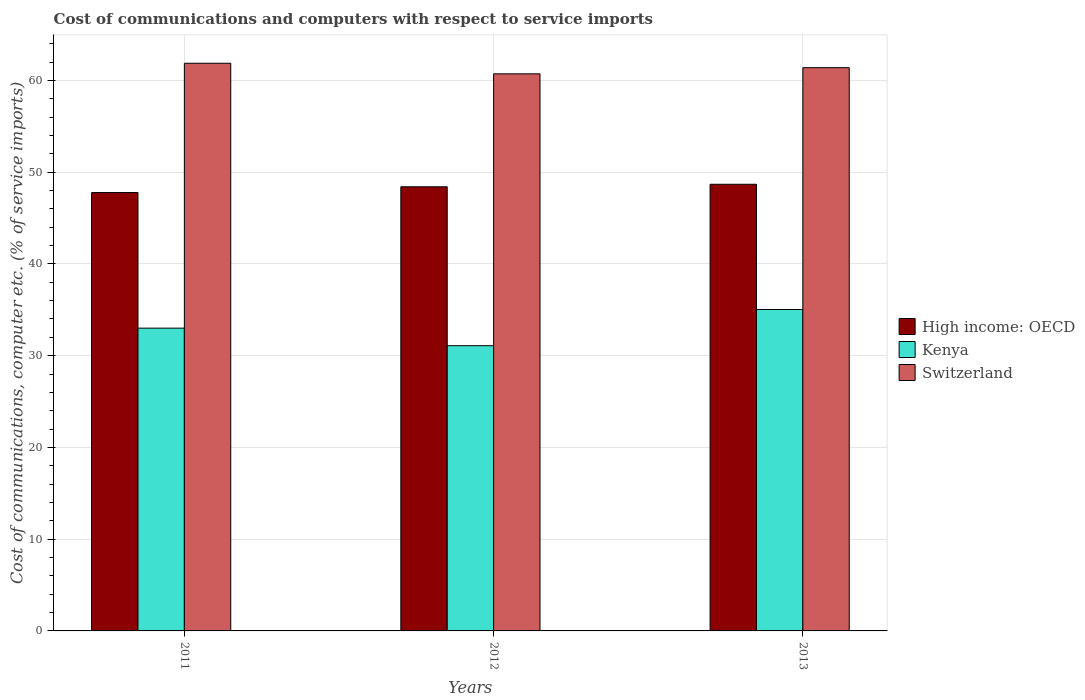How many groups of bars are there?
Ensure brevity in your answer.  3. How many bars are there on the 2nd tick from the left?
Make the answer very short. 3. How many bars are there on the 2nd tick from the right?
Make the answer very short. 3. What is the label of the 1st group of bars from the left?
Keep it short and to the point. 2011. What is the cost of communications and computers in High income: OECD in 2011?
Ensure brevity in your answer.  47.78. Across all years, what is the maximum cost of communications and computers in Switzerland?
Give a very brief answer. 61.87. Across all years, what is the minimum cost of communications and computers in High income: OECD?
Your response must be concise. 47.78. What is the total cost of communications and computers in Kenya in the graph?
Give a very brief answer. 99.12. What is the difference between the cost of communications and computers in Switzerland in 2012 and that in 2013?
Provide a succinct answer. -0.67. What is the difference between the cost of communications and computers in Kenya in 2012 and the cost of communications and computers in Switzerland in 2013?
Ensure brevity in your answer.  -30.3. What is the average cost of communications and computers in Kenya per year?
Ensure brevity in your answer.  33.04. In the year 2012, what is the difference between the cost of communications and computers in Switzerland and cost of communications and computers in High income: OECD?
Make the answer very short. 12.31. In how many years, is the cost of communications and computers in Switzerland greater than 40 %?
Offer a very short reply. 3. What is the ratio of the cost of communications and computers in High income: OECD in 2011 to that in 2012?
Offer a very short reply. 0.99. Is the difference between the cost of communications and computers in Switzerland in 2012 and 2013 greater than the difference between the cost of communications and computers in High income: OECD in 2012 and 2013?
Make the answer very short. No. What is the difference between the highest and the second highest cost of communications and computers in Kenya?
Offer a terse response. 2.03. What is the difference between the highest and the lowest cost of communications and computers in Kenya?
Provide a succinct answer. 3.94. In how many years, is the cost of communications and computers in Switzerland greater than the average cost of communications and computers in Switzerland taken over all years?
Your response must be concise. 2. What does the 3rd bar from the left in 2011 represents?
Offer a terse response. Switzerland. What does the 2nd bar from the right in 2011 represents?
Ensure brevity in your answer.  Kenya. Is it the case that in every year, the sum of the cost of communications and computers in Kenya and cost of communications and computers in High income: OECD is greater than the cost of communications and computers in Switzerland?
Keep it short and to the point. Yes. Are all the bars in the graph horizontal?
Offer a very short reply. No. How many years are there in the graph?
Keep it short and to the point. 3. What is the difference between two consecutive major ticks on the Y-axis?
Keep it short and to the point. 10. Are the values on the major ticks of Y-axis written in scientific E-notation?
Offer a terse response. No. Does the graph contain grids?
Offer a very short reply. Yes. How many legend labels are there?
Provide a short and direct response. 3. How are the legend labels stacked?
Provide a short and direct response. Vertical. What is the title of the graph?
Your answer should be compact. Cost of communications and computers with respect to service imports. What is the label or title of the Y-axis?
Your response must be concise. Cost of communications, computer etc. (% of service imports). What is the Cost of communications, computer etc. (% of service imports) in High income: OECD in 2011?
Your answer should be compact. 47.78. What is the Cost of communications, computer etc. (% of service imports) of Kenya in 2011?
Offer a very short reply. 33. What is the Cost of communications, computer etc. (% of service imports) of Switzerland in 2011?
Offer a very short reply. 61.87. What is the Cost of communications, computer etc. (% of service imports) in High income: OECD in 2012?
Provide a succinct answer. 48.41. What is the Cost of communications, computer etc. (% of service imports) in Kenya in 2012?
Your answer should be compact. 31.09. What is the Cost of communications, computer etc. (% of service imports) of Switzerland in 2012?
Give a very brief answer. 60.72. What is the Cost of communications, computer etc. (% of service imports) in High income: OECD in 2013?
Your answer should be compact. 48.68. What is the Cost of communications, computer etc. (% of service imports) in Kenya in 2013?
Ensure brevity in your answer.  35.03. What is the Cost of communications, computer etc. (% of service imports) in Switzerland in 2013?
Keep it short and to the point. 61.39. Across all years, what is the maximum Cost of communications, computer etc. (% of service imports) of High income: OECD?
Your response must be concise. 48.68. Across all years, what is the maximum Cost of communications, computer etc. (% of service imports) of Kenya?
Keep it short and to the point. 35.03. Across all years, what is the maximum Cost of communications, computer etc. (% of service imports) of Switzerland?
Give a very brief answer. 61.87. Across all years, what is the minimum Cost of communications, computer etc. (% of service imports) of High income: OECD?
Make the answer very short. 47.78. Across all years, what is the minimum Cost of communications, computer etc. (% of service imports) in Kenya?
Offer a terse response. 31.09. Across all years, what is the minimum Cost of communications, computer etc. (% of service imports) in Switzerland?
Keep it short and to the point. 60.72. What is the total Cost of communications, computer etc. (% of service imports) in High income: OECD in the graph?
Provide a short and direct response. 144.87. What is the total Cost of communications, computer etc. (% of service imports) of Kenya in the graph?
Your response must be concise. 99.12. What is the total Cost of communications, computer etc. (% of service imports) of Switzerland in the graph?
Provide a succinct answer. 183.98. What is the difference between the Cost of communications, computer etc. (% of service imports) of High income: OECD in 2011 and that in 2012?
Your answer should be compact. -0.63. What is the difference between the Cost of communications, computer etc. (% of service imports) of Kenya in 2011 and that in 2012?
Give a very brief answer. 1.91. What is the difference between the Cost of communications, computer etc. (% of service imports) in Switzerland in 2011 and that in 2012?
Your answer should be very brief. 1.15. What is the difference between the Cost of communications, computer etc. (% of service imports) in High income: OECD in 2011 and that in 2013?
Provide a short and direct response. -0.9. What is the difference between the Cost of communications, computer etc. (% of service imports) in Kenya in 2011 and that in 2013?
Offer a very short reply. -2.03. What is the difference between the Cost of communications, computer etc. (% of service imports) in Switzerland in 2011 and that in 2013?
Provide a short and direct response. 0.48. What is the difference between the Cost of communications, computer etc. (% of service imports) in High income: OECD in 2012 and that in 2013?
Keep it short and to the point. -0.27. What is the difference between the Cost of communications, computer etc. (% of service imports) in Kenya in 2012 and that in 2013?
Your answer should be very brief. -3.94. What is the difference between the Cost of communications, computer etc. (% of service imports) of Switzerland in 2012 and that in 2013?
Provide a succinct answer. -0.67. What is the difference between the Cost of communications, computer etc. (% of service imports) of High income: OECD in 2011 and the Cost of communications, computer etc. (% of service imports) of Kenya in 2012?
Your response must be concise. 16.69. What is the difference between the Cost of communications, computer etc. (% of service imports) of High income: OECD in 2011 and the Cost of communications, computer etc. (% of service imports) of Switzerland in 2012?
Give a very brief answer. -12.94. What is the difference between the Cost of communications, computer etc. (% of service imports) of Kenya in 2011 and the Cost of communications, computer etc. (% of service imports) of Switzerland in 2012?
Your answer should be very brief. -27.72. What is the difference between the Cost of communications, computer etc. (% of service imports) in High income: OECD in 2011 and the Cost of communications, computer etc. (% of service imports) in Kenya in 2013?
Ensure brevity in your answer.  12.75. What is the difference between the Cost of communications, computer etc. (% of service imports) in High income: OECD in 2011 and the Cost of communications, computer etc. (% of service imports) in Switzerland in 2013?
Offer a terse response. -13.61. What is the difference between the Cost of communications, computer etc. (% of service imports) in Kenya in 2011 and the Cost of communications, computer etc. (% of service imports) in Switzerland in 2013?
Ensure brevity in your answer.  -28.39. What is the difference between the Cost of communications, computer etc. (% of service imports) in High income: OECD in 2012 and the Cost of communications, computer etc. (% of service imports) in Kenya in 2013?
Make the answer very short. 13.37. What is the difference between the Cost of communications, computer etc. (% of service imports) in High income: OECD in 2012 and the Cost of communications, computer etc. (% of service imports) in Switzerland in 2013?
Ensure brevity in your answer.  -12.98. What is the difference between the Cost of communications, computer etc. (% of service imports) in Kenya in 2012 and the Cost of communications, computer etc. (% of service imports) in Switzerland in 2013?
Keep it short and to the point. -30.3. What is the average Cost of communications, computer etc. (% of service imports) in High income: OECD per year?
Your answer should be very brief. 48.29. What is the average Cost of communications, computer etc. (% of service imports) in Kenya per year?
Give a very brief answer. 33.04. What is the average Cost of communications, computer etc. (% of service imports) of Switzerland per year?
Offer a terse response. 61.33. In the year 2011, what is the difference between the Cost of communications, computer etc. (% of service imports) in High income: OECD and Cost of communications, computer etc. (% of service imports) in Kenya?
Your response must be concise. 14.78. In the year 2011, what is the difference between the Cost of communications, computer etc. (% of service imports) in High income: OECD and Cost of communications, computer etc. (% of service imports) in Switzerland?
Your answer should be very brief. -14.09. In the year 2011, what is the difference between the Cost of communications, computer etc. (% of service imports) in Kenya and Cost of communications, computer etc. (% of service imports) in Switzerland?
Make the answer very short. -28.87. In the year 2012, what is the difference between the Cost of communications, computer etc. (% of service imports) in High income: OECD and Cost of communications, computer etc. (% of service imports) in Kenya?
Your answer should be compact. 17.32. In the year 2012, what is the difference between the Cost of communications, computer etc. (% of service imports) in High income: OECD and Cost of communications, computer etc. (% of service imports) in Switzerland?
Make the answer very short. -12.31. In the year 2012, what is the difference between the Cost of communications, computer etc. (% of service imports) in Kenya and Cost of communications, computer etc. (% of service imports) in Switzerland?
Make the answer very short. -29.63. In the year 2013, what is the difference between the Cost of communications, computer etc. (% of service imports) in High income: OECD and Cost of communications, computer etc. (% of service imports) in Kenya?
Your response must be concise. 13.65. In the year 2013, what is the difference between the Cost of communications, computer etc. (% of service imports) in High income: OECD and Cost of communications, computer etc. (% of service imports) in Switzerland?
Give a very brief answer. -12.71. In the year 2013, what is the difference between the Cost of communications, computer etc. (% of service imports) in Kenya and Cost of communications, computer etc. (% of service imports) in Switzerland?
Provide a short and direct response. -26.36. What is the ratio of the Cost of communications, computer etc. (% of service imports) in High income: OECD in 2011 to that in 2012?
Provide a short and direct response. 0.99. What is the ratio of the Cost of communications, computer etc. (% of service imports) of Kenya in 2011 to that in 2012?
Your answer should be very brief. 1.06. What is the ratio of the Cost of communications, computer etc. (% of service imports) of High income: OECD in 2011 to that in 2013?
Ensure brevity in your answer.  0.98. What is the ratio of the Cost of communications, computer etc. (% of service imports) in Kenya in 2011 to that in 2013?
Provide a succinct answer. 0.94. What is the ratio of the Cost of communications, computer etc. (% of service imports) in Switzerland in 2011 to that in 2013?
Your response must be concise. 1.01. What is the ratio of the Cost of communications, computer etc. (% of service imports) of High income: OECD in 2012 to that in 2013?
Give a very brief answer. 0.99. What is the ratio of the Cost of communications, computer etc. (% of service imports) in Kenya in 2012 to that in 2013?
Provide a succinct answer. 0.89. What is the difference between the highest and the second highest Cost of communications, computer etc. (% of service imports) of High income: OECD?
Ensure brevity in your answer.  0.27. What is the difference between the highest and the second highest Cost of communications, computer etc. (% of service imports) in Kenya?
Your answer should be compact. 2.03. What is the difference between the highest and the second highest Cost of communications, computer etc. (% of service imports) in Switzerland?
Give a very brief answer. 0.48. What is the difference between the highest and the lowest Cost of communications, computer etc. (% of service imports) in High income: OECD?
Provide a succinct answer. 0.9. What is the difference between the highest and the lowest Cost of communications, computer etc. (% of service imports) of Kenya?
Offer a terse response. 3.94. What is the difference between the highest and the lowest Cost of communications, computer etc. (% of service imports) of Switzerland?
Offer a very short reply. 1.15. 